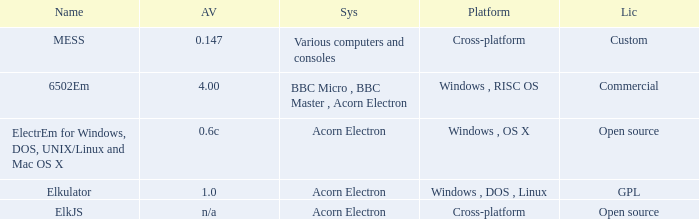What is the name of the platform used for various computers and consoles? Cross-platform. Could you parse the entire table? {'header': ['Name', 'AV', 'Sys', 'Platform', 'Lic'], 'rows': [['MESS', '0.147', 'Various computers and consoles', 'Cross-platform', 'Custom'], ['6502Em', '4.00', 'BBC Micro , BBC Master , Acorn Electron', 'Windows , RISC OS', 'Commercial'], ['ElectrEm for Windows, DOS, UNIX/Linux and Mac OS X', '0.6c', 'Acorn Electron', 'Windows , OS X', 'Open source'], ['Elkulator', '1.0', 'Acorn Electron', 'Windows , DOS , Linux', 'GPL'], ['ElkJS', 'n/a', 'Acorn Electron', 'Cross-platform', 'Open source']]} 